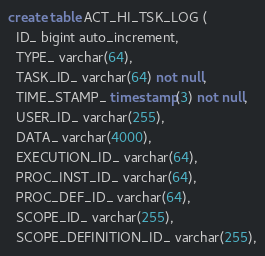<code> <loc_0><loc_0><loc_500><loc_500><_SQL_>create table ACT_HI_TSK_LOG (
  ID_ bigint auto_increment,
  TYPE_ varchar(64),
  TASK_ID_ varchar(64) not null,
  TIME_STAMP_ timestamp(3) not null,
  USER_ID_ varchar(255),
  DATA_ varchar(4000),
  EXECUTION_ID_ varchar(64),
  PROC_INST_ID_ varchar(64),
  PROC_DEF_ID_ varchar(64),
  SCOPE_ID_ varchar(255),
  SCOPE_DEFINITION_ID_ varchar(255),</code> 